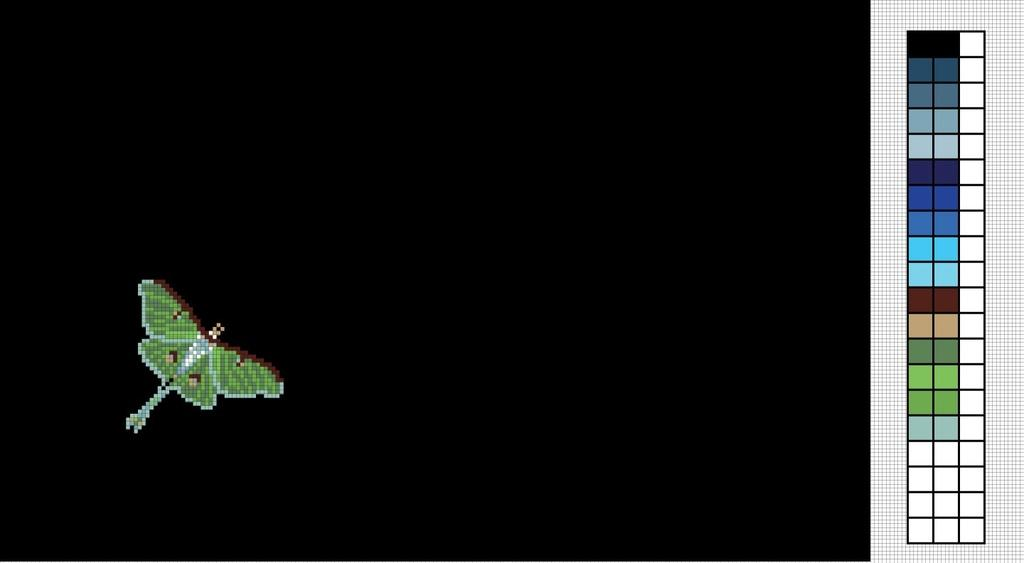What type of image is being described? The image is animated. What can be seen flying in the animated image? There is an animated butterfly in the image. What other objects are present in the image? There are color boxes in the image. How would you describe the overall appearance of the image? The background of the image is dark. How many oranges are hanging from the butterfly's wings in the image? There are no oranges present in the image, and the butterfly's wings do not have any attached to them. 